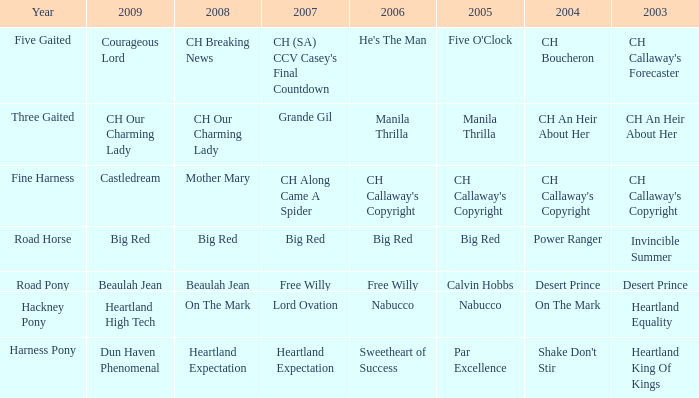When does the "shake don't stir" from 2004 occur? Harness Pony. Can you give me this table as a dict? {'header': ['Year', '2009', '2008', '2007', '2006', '2005', '2004', '2003'], 'rows': [['Five Gaited', 'Courageous Lord', 'CH Breaking News', "CH (SA) CCV Casey's Final Countdown", "He's The Man", "Five O'Clock", 'CH Boucheron', "CH Callaway's Forecaster"], ['Three Gaited', 'CH Our Charming Lady', 'CH Our Charming Lady', 'Grande Gil', 'Manila Thrilla', 'Manila Thrilla', 'CH An Heir About Her', 'CH An Heir About Her'], ['Fine Harness', 'Castledream', 'Mother Mary', 'CH Along Came A Spider', "CH Callaway's Copyright", "CH Callaway's Copyright", "CH Callaway's Copyright", "CH Callaway's Copyright"], ['Road Horse', 'Big Red', 'Big Red', 'Big Red', 'Big Red', 'Big Red', 'Power Ranger', 'Invincible Summer'], ['Road Pony', 'Beaulah Jean', 'Beaulah Jean', 'Free Willy', 'Free Willy', 'Calvin Hobbs', 'Desert Prince', 'Desert Prince'], ['Hackney Pony', 'Heartland High Tech', 'On The Mark', 'Lord Ovation', 'Nabucco', 'Nabucco', 'On The Mark', 'Heartland Equality'], ['Harness Pony', 'Dun Haven Phenomenal', 'Heartland Expectation', 'Heartland Expectation', 'Sweetheart of Success', 'Par Excellence', "Shake Don't Stir", 'Heartland King Of Kings']]} 